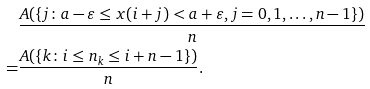<formula> <loc_0><loc_0><loc_500><loc_500>& \frac { A ( \{ j \colon a - \varepsilon \leq x ( i + j ) < a + \varepsilon , j = 0 , 1 , \dots , n - 1 \} ) } { n } \\ = & \frac { A ( \{ k \colon i \leq n _ { k } \leq i + n - 1 \} ) } { n } .</formula> 